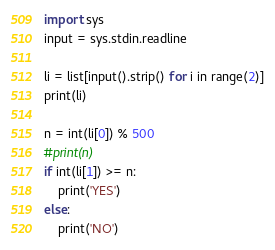Convert code to text. <code><loc_0><loc_0><loc_500><loc_500><_Python_>import sys
input = sys.stdin.readline

li = list[input().strip() for i in range(2)]
print(li)

n = int(li[0]) % 500
#print(n)
if int(li[1]) >= n:
    print('YES')
else:
    print('NO')
</code> 